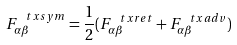<formula> <loc_0><loc_0><loc_500><loc_500>F ^ { \ t x { s y m } } _ { \alpha \beta } = \frac { 1 } { 2 } ( F ^ { \ t x { r e t } } _ { \alpha \beta } + F ^ { \ t x { a d v } } _ { \alpha \beta } )</formula> 